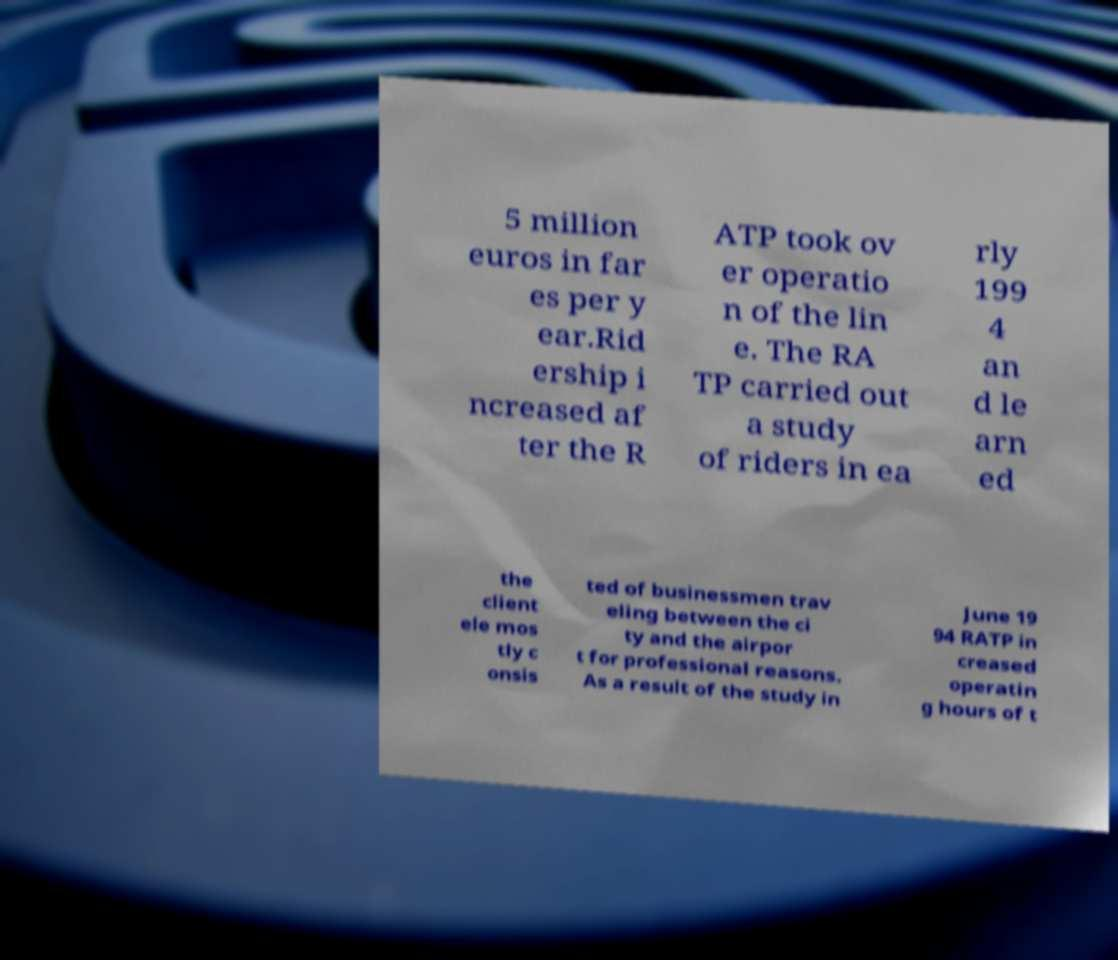Can you accurately transcribe the text from the provided image for me? 5 million euros in far es per y ear.Rid ership i ncreased af ter the R ATP took ov er operatio n of the lin e. The RA TP carried out a study of riders in ea rly 199 4 an d le arn ed the client ele mos tly c onsis ted of businessmen trav eling between the ci ty and the airpor t for professional reasons. As a result of the study in June 19 94 RATP in creased operatin g hours of t 